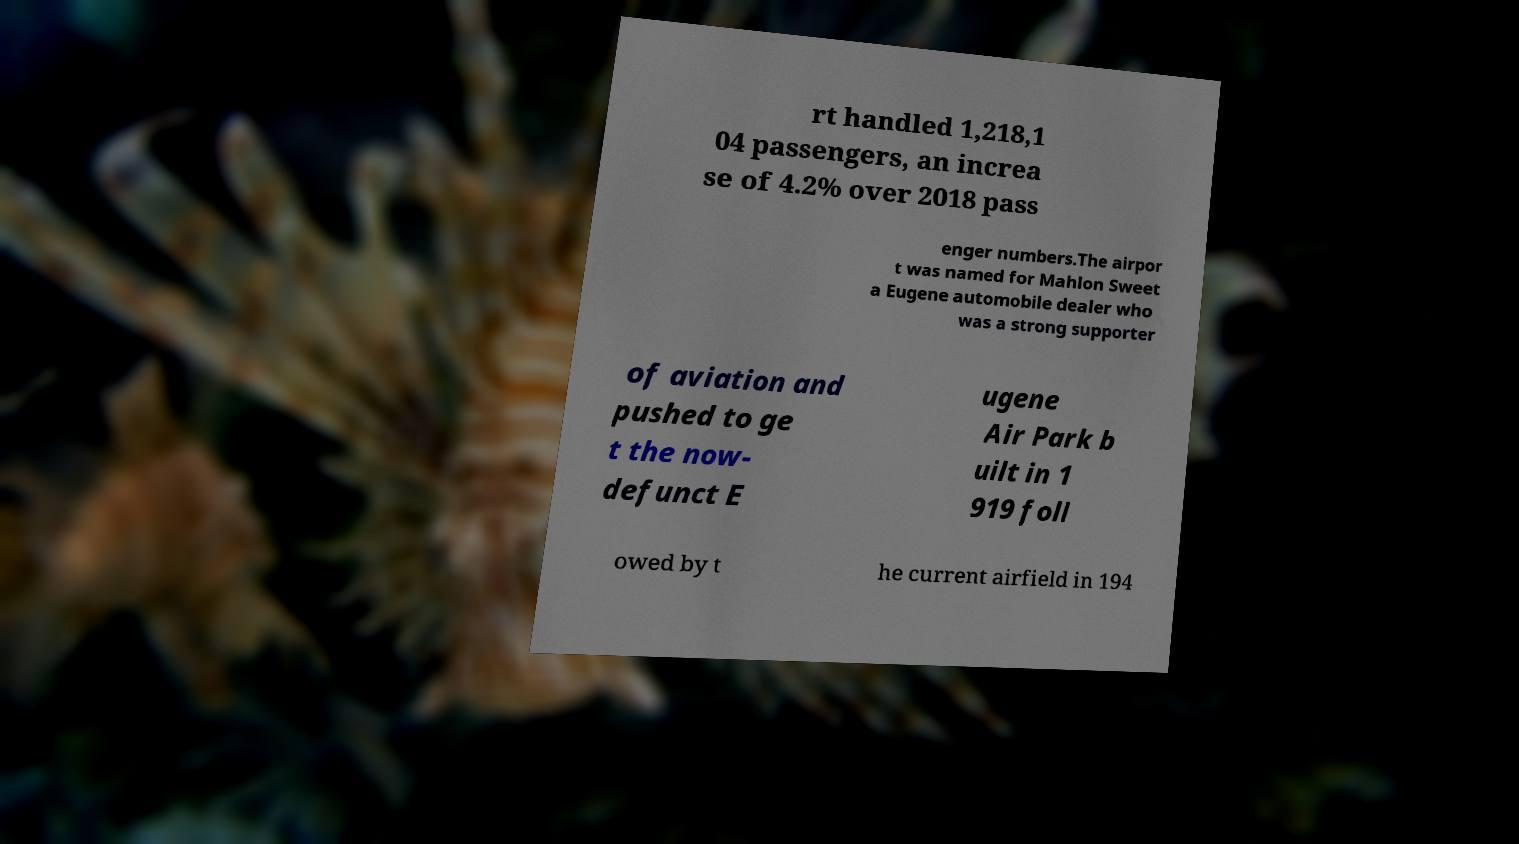There's text embedded in this image that I need extracted. Can you transcribe it verbatim? rt handled 1,218,1 04 passengers, an increa se of 4.2% over 2018 pass enger numbers.The airpor t was named for Mahlon Sweet a Eugene automobile dealer who was a strong supporter of aviation and pushed to ge t the now- defunct E ugene Air Park b uilt in 1 919 foll owed by t he current airfield in 194 